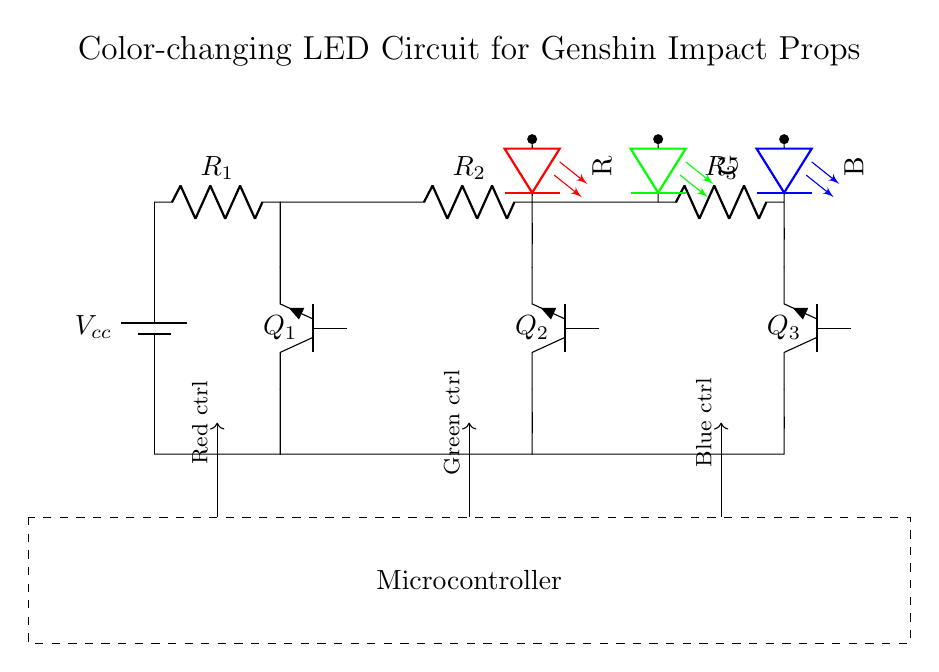What type of transistors are used in this circuit? The circuit uses NPN transistors, which can be identified by the label "Tnpn" next to the transistor symbols.
Answer: NPN How many resistors are in the circuit? The circuit diagram shows three resistors labeled R1, R2, and R3. This can be counted by identifying the resistor symbols in the diagram.
Answer: 3 What is the purpose of the microcontroller? The microcontroller is used to control the color changes of the RGB LED by sending control signals for each color. It is represented by the dashed rectangle labeled "Microcontroller."
Answer: Control Which colors does the LED emit in this circuit? The RGB LED emits red, green, and blue colors, as indicated by the color labels next to each LED symbol.
Answer: Red, Green, Blue How are the RGB LEDs connected to the transistors? Each RGB LED is connected in series with its corresponding NPN transistor, meaning the LED anodes connect to the collectors of the respective transistors.
Answer: Series What is the orientation of the LED colors in the circuit? The red LED is on the left, the green LED is in the middle, and the blue LED is on the right, visually indicating their arrangement in the circuit.
Answer: Left, Middle, Right What kind of power supply is used in the circuit? The diagram shows a battery symbol that indicates a DC power supply labeled as Vcc at the top of the circuit.
Answer: Battery 